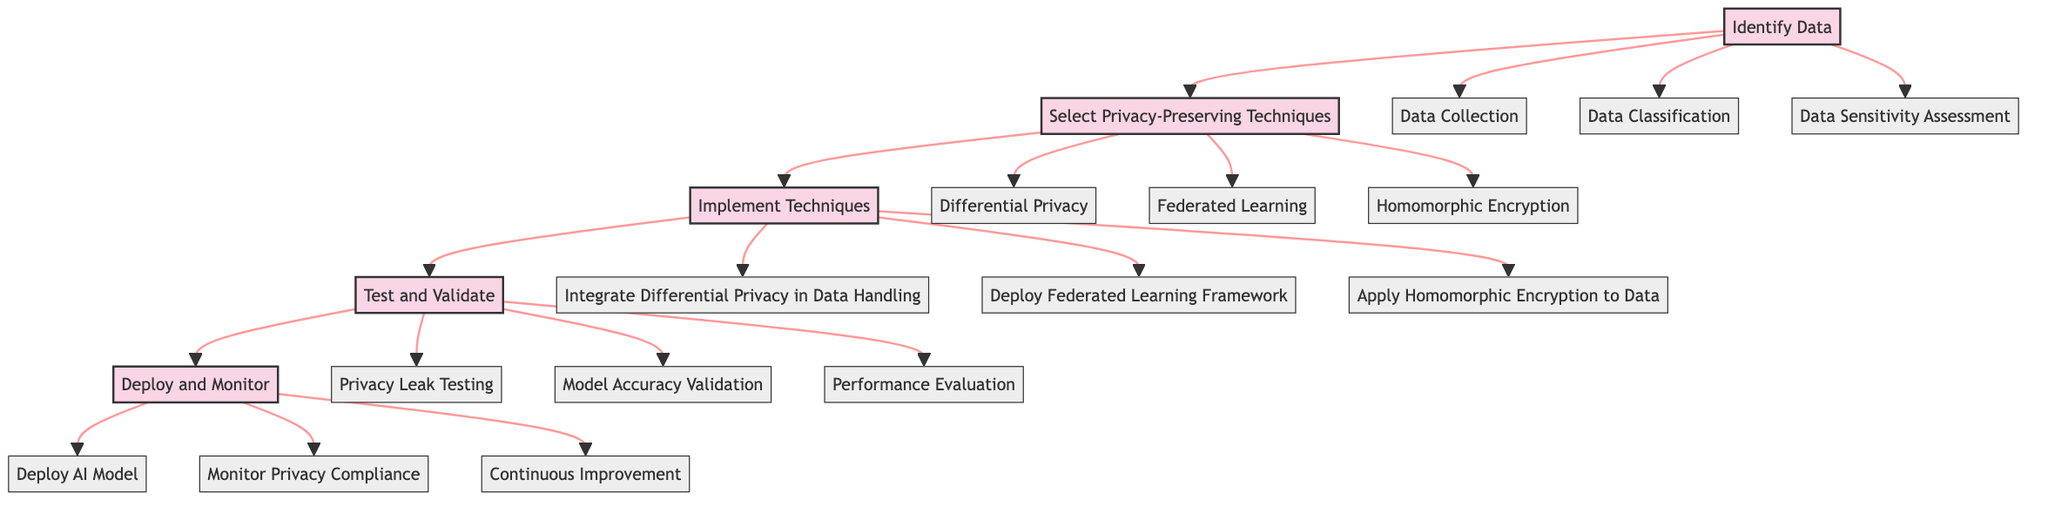What is the first stage in the workflow? The diagram indicates that the first stage is "Identify Data," which is visually represented as the first node in the flowchart.
Answer: Identify Data How many privacy-preserving techniques are listed? The flowchart includes three techniques under the "Select Privacy-Preserving Techniques" stage, which are visibly connected to that stage in the diagram.
Answer: Three What is one component under "Test and Validate"? The diagram shows three components under the "Test and Validate" stage, and one of them is "Privacy Leak Testing," which can be found as an outgoing node from that stage.
Answer: Privacy Leak Testing Which stage comes after "Implement Techniques"? Following the flow of the diagram, the stage that directly connects to "Implement Techniques" is "Test and Validate," represented by an arrow indicating the direction of the workflow.
Answer: Test and Validate How do you monitor privacy compliance according to the diagram? The flowchart indicates that monitoring privacy compliance is a component of the "Deploy and Monitor" stage, specifically labeled as "Monitor Privacy Compliance."
Answer: Monitor Privacy Compliance Which technique is listed for data handling? Under the "Implement Techniques" stage, the component "Integrate Differential Privacy in Data Handling" pertains to managing data while ensuring privacy.
Answer: Integrate Differential Privacy in Data Handling What are the components under the "Select Privacy-Preserving Techniques" stage? The diagram specifically shows three components under this stage: "Differential Privacy," "Federated Learning," and "Homomorphic Encryption," which are linked to the stage as options for selection.
Answer: Differential Privacy, Federated Learning, Homomorphic Encryption What is the last stage in the workflow? The diagram identifies "Deploy and Monitor" as the final stage, which has no outgoing connections to any other stages, indicating it concludes the workflow.
Answer: Deploy and Monitor 